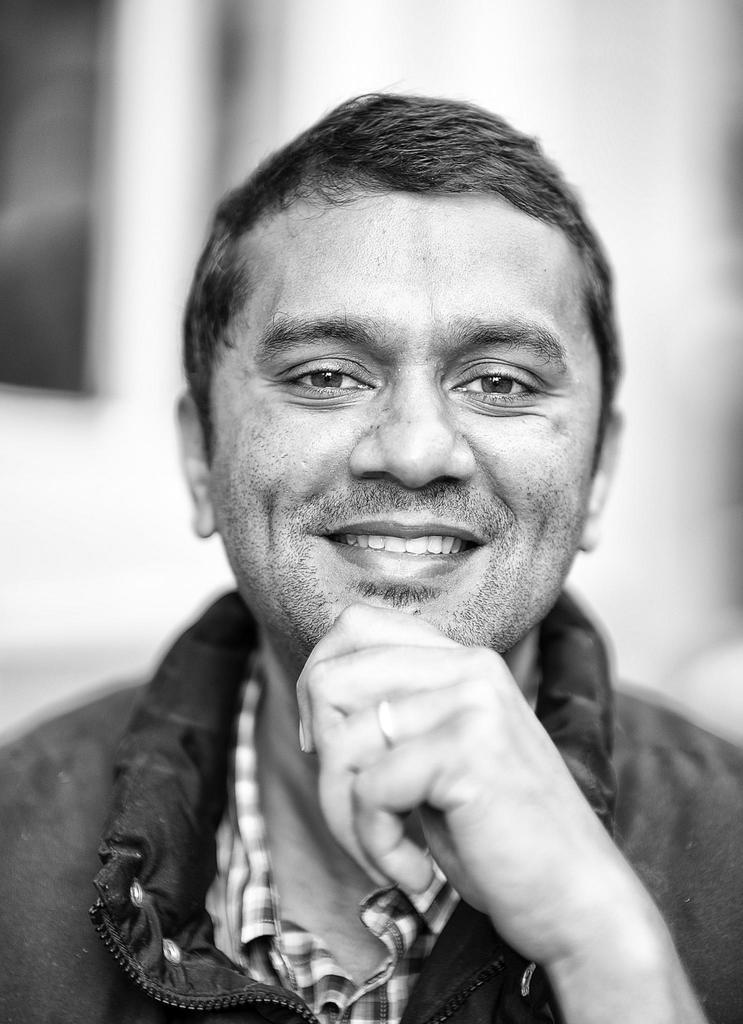Who is present in the image? There is a man in the picture. What is the man's facial expression? The man is smiling. What can be seen in the background of the image? There appears to be a building in the background of the picture. What type of birthday meal is the man eating in the image? There is no indication of a birthday or meal in the image; it simply shows a man smiling with a building in the background. 